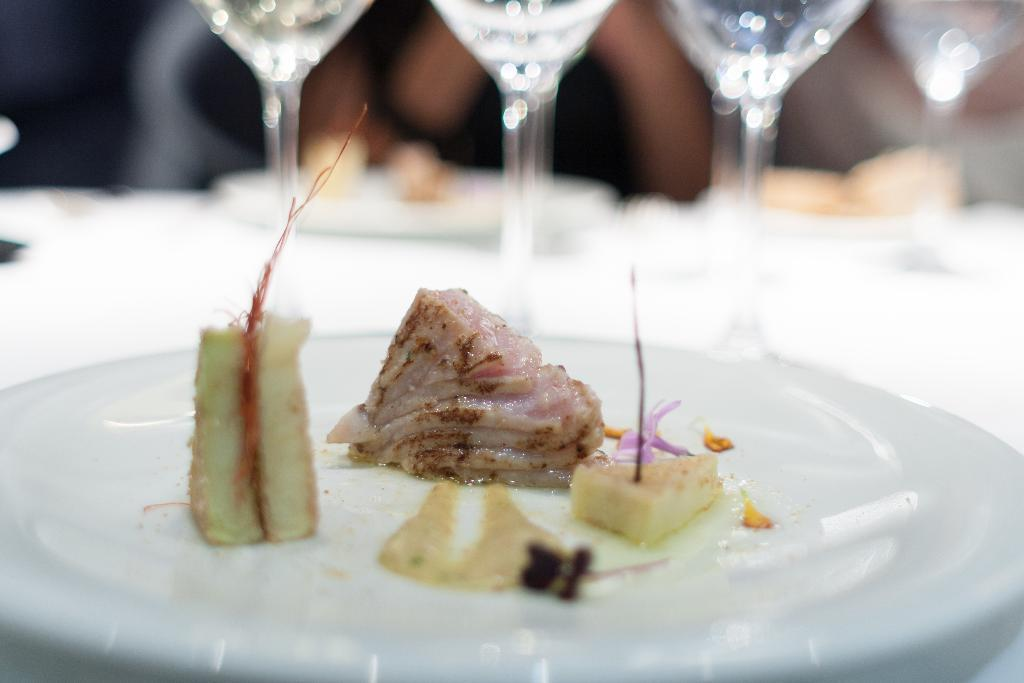What is on the table in the image? There is a plate on the table. What is on the plate? The plate contains food. How many glasses can be seen in the image? There are multiple glasses in the image. What type of nail is being used to hold the plate in place in the image? There is no nail present in the image, and the plate is not being held in place by any visible means. 